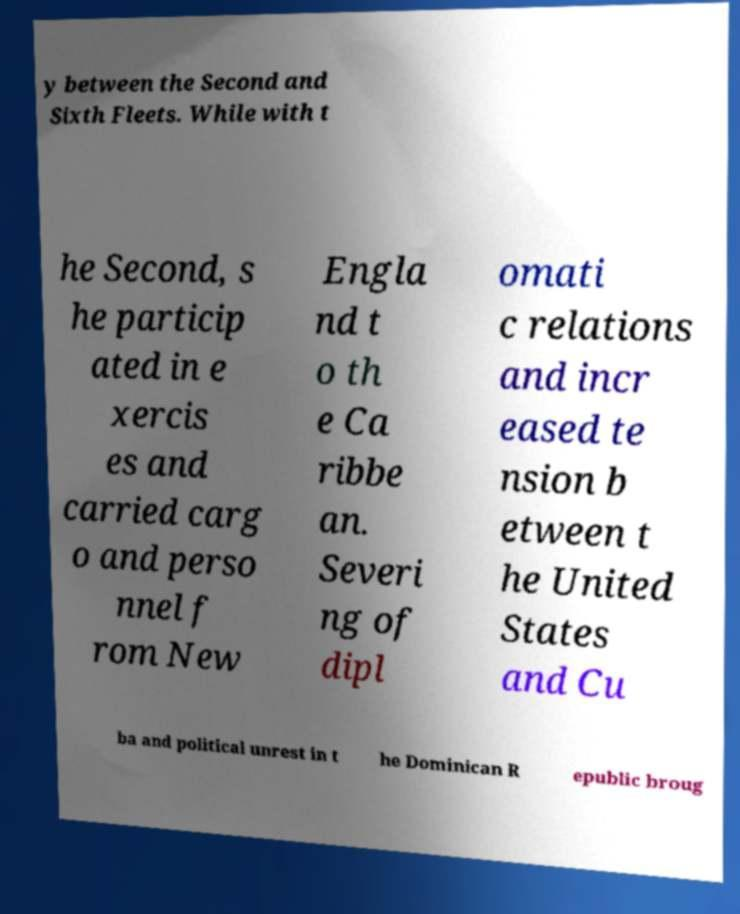Could you extract and type out the text from this image? y between the Second and Sixth Fleets. While with t he Second, s he particip ated in e xercis es and carried carg o and perso nnel f rom New Engla nd t o th e Ca ribbe an. Severi ng of dipl omati c relations and incr eased te nsion b etween t he United States and Cu ba and political unrest in t he Dominican R epublic broug 